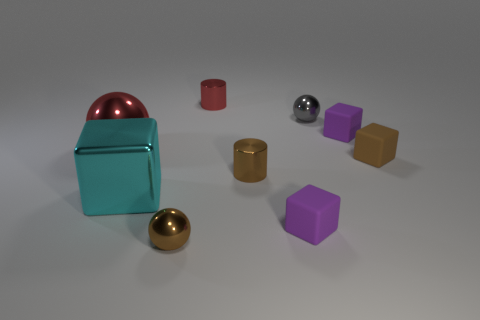Add 1 large shiny balls. How many objects exist? 10 Subtract all blocks. How many objects are left? 5 Add 3 big metal balls. How many big metal balls exist? 4 Subtract 0 green cylinders. How many objects are left? 9 Subtract all small brown metal cylinders. Subtract all brown cylinders. How many objects are left? 7 Add 6 tiny gray shiny things. How many tiny gray shiny things are left? 7 